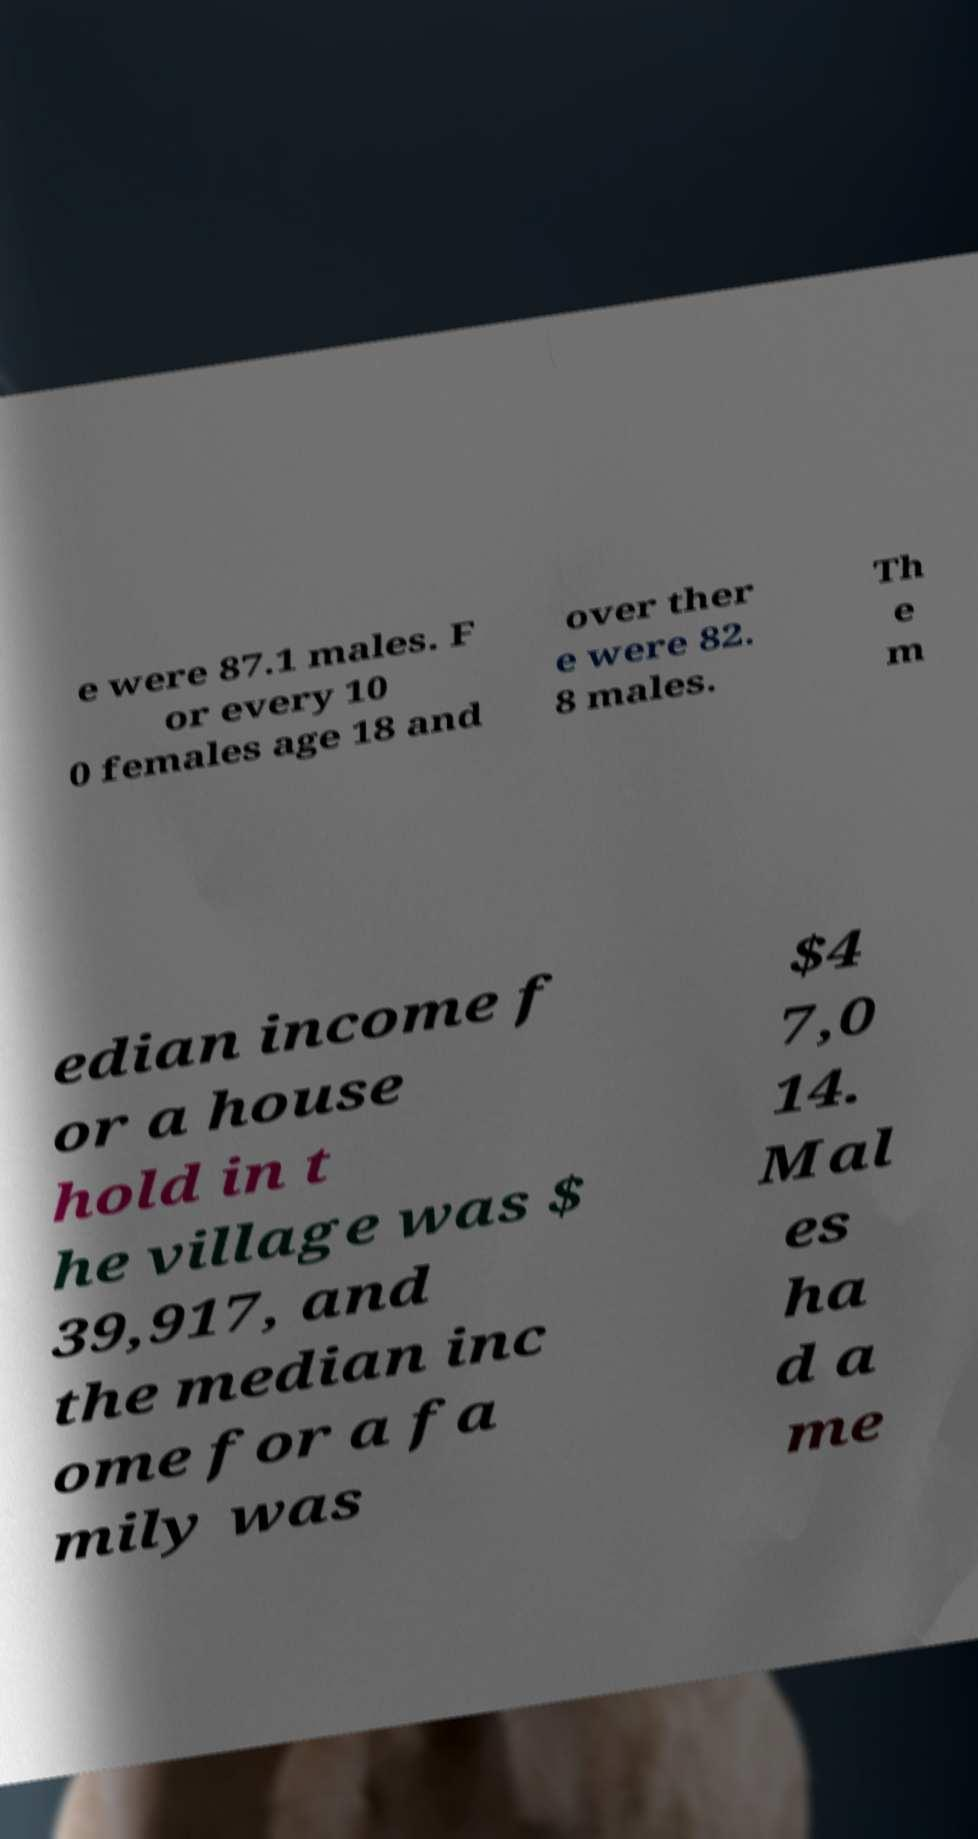There's text embedded in this image that I need extracted. Can you transcribe it verbatim? e were 87.1 males. F or every 10 0 females age 18 and over ther e were 82. 8 males. Th e m edian income f or a house hold in t he village was $ 39,917, and the median inc ome for a fa mily was $4 7,0 14. Mal es ha d a me 